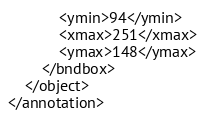Convert code to text. <code><loc_0><loc_0><loc_500><loc_500><_XML_>			<ymin>94</ymin>
			<xmax>251</xmax>
			<ymax>148</ymax>
		</bndbox>
	</object>
</annotation>
</code> 